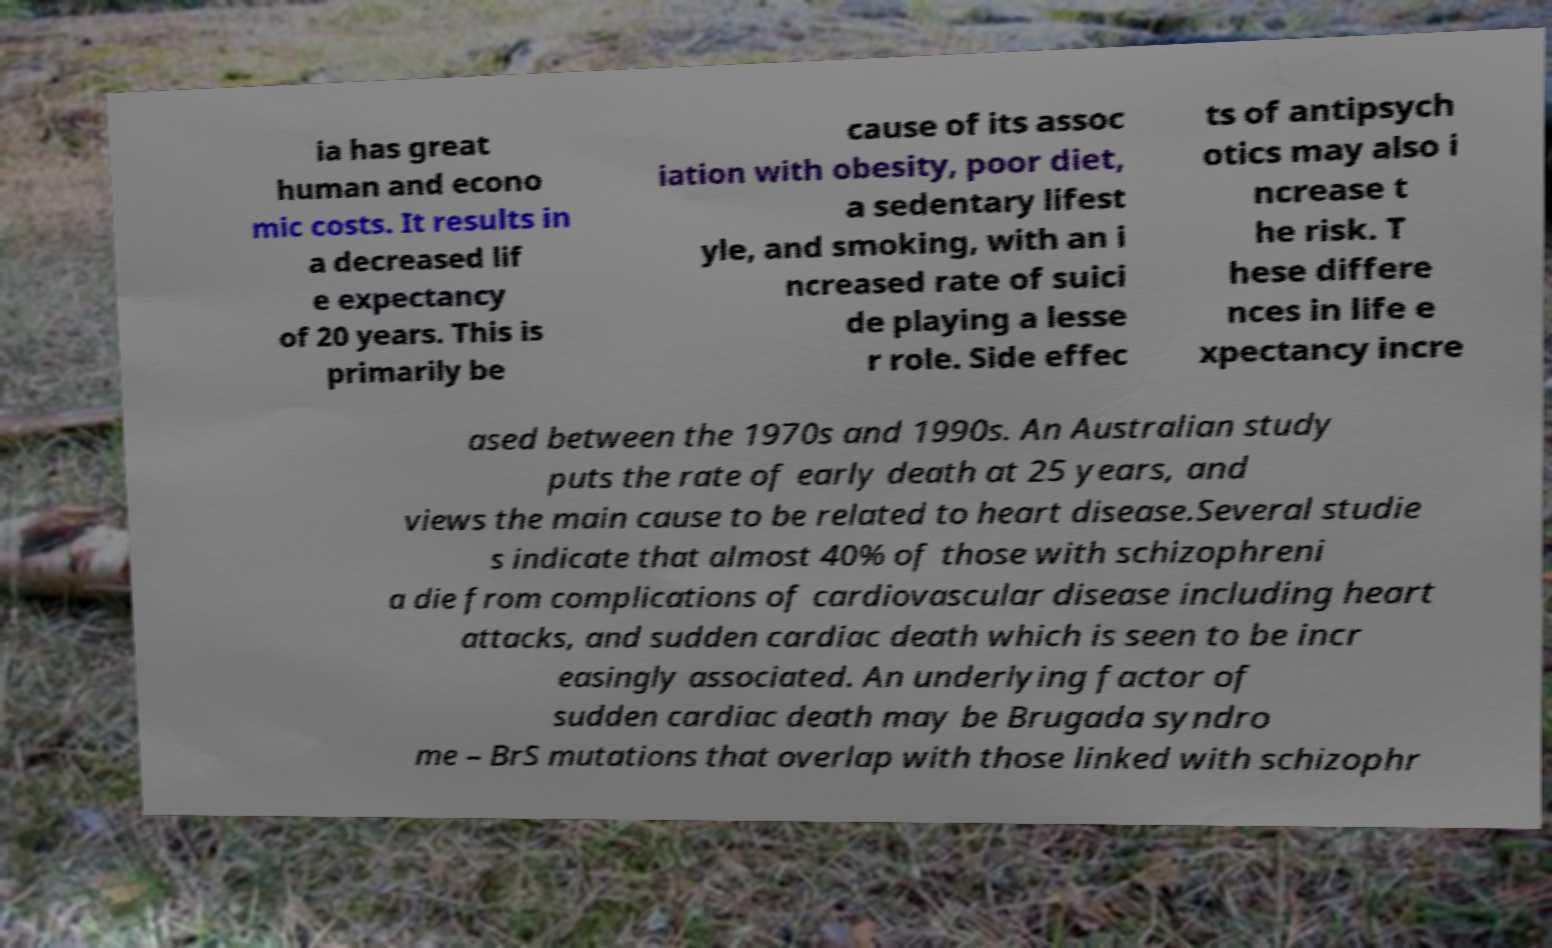For documentation purposes, I need the text within this image transcribed. Could you provide that? ia has great human and econo mic costs. It results in a decreased lif e expectancy of 20 years. This is primarily be cause of its assoc iation with obesity, poor diet, a sedentary lifest yle, and smoking, with an i ncreased rate of suici de playing a lesse r role. Side effec ts of antipsych otics may also i ncrease t he risk. T hese differe nces in life e xpectancy incre ased between the 1970s and 1990s. An Australian study puts the rate of early death at 25 years, and views the main cause to be related to heart disease.Several studie s indicate that almost 40% of those with schizophreni a die from complications of cardiovascular disease including heart attacks, and sudden cardiac death which is seen to be incr easingly associated. An underlying factor of sudden cardiac death may be Brugada syndro me – BrS mutations that overlap with those linked with schizophr 